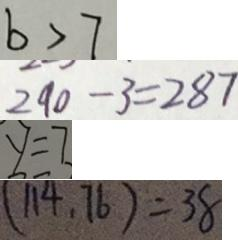<formula> <loc_0><loc_0><loc_500><loc_500>b > 7 
 2 9 0 - 3 = 2 8 7 
 y = 7 
 ( 1 1 4 . 7 6 ) = 3 8</formula> 